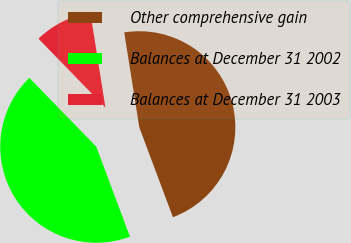Convert chart. <chart><loc_0><loc_0><loc_500><loc_500><pie_chart><fcel>Other comprehensive gain<fcel>Balances at December 31 2002<fcel>Balances at December 31 2003<nl><fcel>46.81%<fcel>43.42%<fcel>9.77%<nl></chart> 